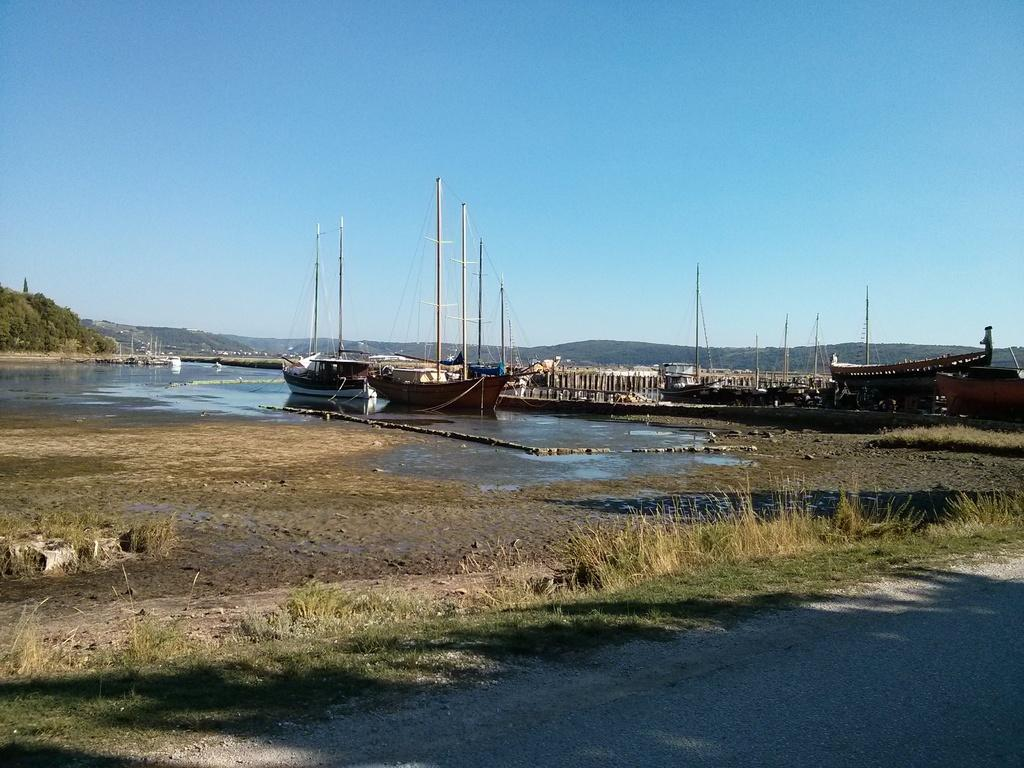What type of terrain is visible in the image? There is grass on the ground in the image. What can be seen in the background of the image? Water, boats, trees, and the sky are visible in the background of the image. How many sisters are playing with the fireman in the image? There are no sisters or firemen present in the image. 